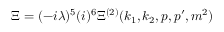<formula> <loc_0><loc_0><loc_500><loc_500>\Xi = ( - i \lambda ) ^ { 5 } ( i ) ^ { 6 } \Xi ^ { ( 2 ) } ( k _ { 1 } , k _ { 2 } , p , p ^ { \prime } , m ^ { 2 } )</formula> 